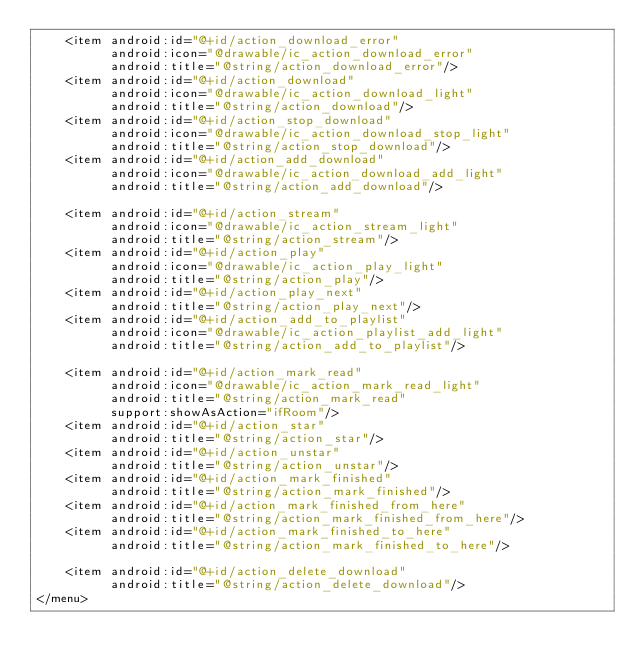Convert code to text. <code><loc_0><loc_0><loc_500><loc_500><_XML_>    <item android:id="@+id/action_download_error"
          android:icon="@drawable/ic_action_download_error"
          android:title="@string/action_download_error"/>
    <item android:id="@+id/action_download"
          android:icon="@drawable/ic_action_download_light"
          android:title="@string/action_download"/>
    <item android:id="@+id/action_stop_download"
          android:icon="@drawable/ic_action_download_stop_light"
          android:title="@string/action_stop_download"/>
    <item android:id="@+id/action_add_download"
          android:icon="@drawable/ic_action_download_add_light"
          android:title="@string/action_add_download"/>

    <item android:id="@+id/action_stream"
          android:icon="@drawable/ic_action_stream_light"
          android:title="@string/action_stream"/>
    <item android:id="@+id/action_play"
          android:icon="@drawable/ic_action_play_light"
          android:title="@string/action_play"/>
    <item android:id="@+id/action_play_next"
          android:title="@string/action_play_next"/>
    <item android:id="@+id/action_add_to_playlist"
          android:icon="@drawable/ic_action_playlist_add_light"
          android:title="@string/action_add_to_playlist"/>

    <item android:id="@+id/action_mark_read"
          android:icon="@drawable/ic_action_mark_read_light"
          android:title="@string/action_mark_read"
          support:showAsAction="ifRoom"/>
    <item android:id="@+id/action_star"
          android:title="@string/action_star"/>
    <item android:id="@+id/action_unstar"
          android:title="@string/action_unstar"/>
    <item android:id="@+id/action_mark_finished"
          android:title="@string/action_mark_finished"/>
    <item android:id="@+id/action_mark_finished_from_here"
          android:title="@string/action_mark_finished_from_here"/>
    <item android:id="@+id/action_mark_finished_to_here"
          android:title="@string/action_mark_finished_to_here"/>

    <item android:id="@+id/action_delete_download"
          android:title="@string/action_delete_download"/>
</menu>
</code> 